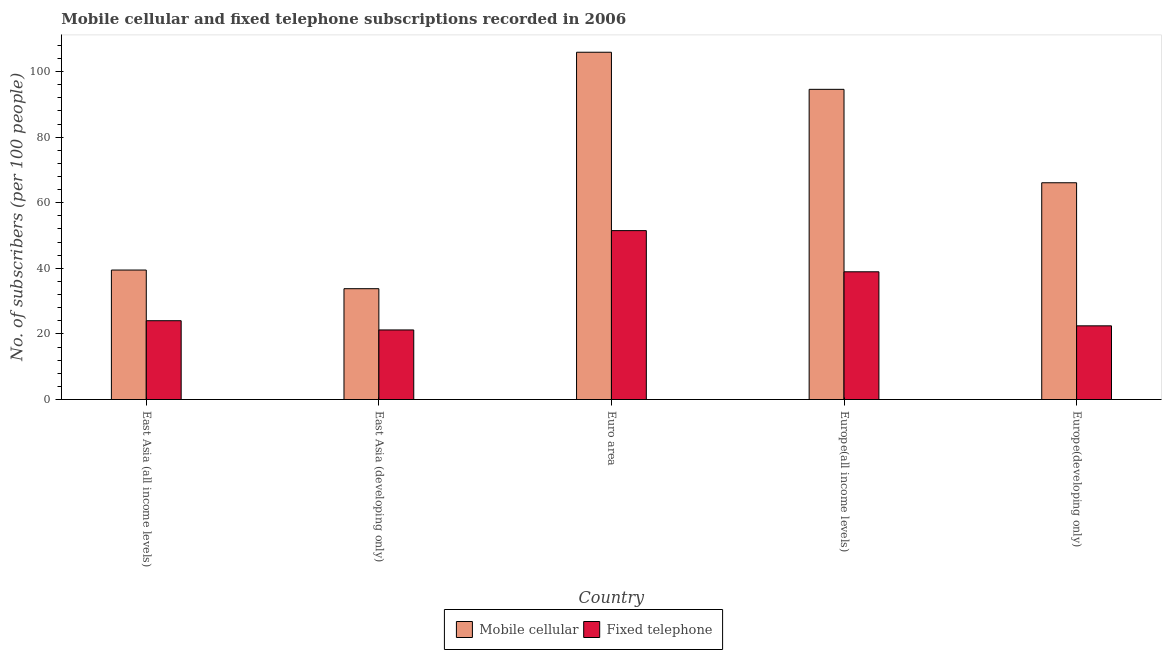How many groups of bars are there?
Give a very brief answer. 5. Are the number of bars on each tick of the X-axis equal?
Offer a very short reply. Yes. How many bars are there on the 4th tick from the right?
Make the answer very short. 2. What is the number of mobile cellular subscribers in Europe(developing only)?
Provide a succinct answer. 66.09. Across all countries, what is the maximum number of mobile cellular subscribers?
Ensure brevity in your answer.  105.89. Across all countries, what is the minimum number of fixed telephone subscribers?
Offer a very short reply. 21.21. In which country was the number of fixed telephone subscribers maximum?
Your answer should be compact. Euro area. In which country was the number of fixed telephone subscribers minimum?
Keep it short and to the point. East Asia (developing only). What is the total number of mobile cellular subscribers in the graph?
Make the answer very short. 339.83. What is the difference between the number of mobile cellular subscribers in Euro area and that in Europe(all income levels)?
Give a very brief answer. 11.31. What is the difference between the number of fixed telephone subscribers in East Asia (developing only) and the number of mobile cellular subscribers in Europe(all income levels)?
Ensure brevity in your answer.  -73.36. What is the average number of fixed telephone subscribers per country?
Keep it short and to the point. 31.63. What is the difference between the number of mobile cellular subscribers and number of fixed telephone subscribers in East Asia (developing only)?
Your answer should be compact. 12.58. What is the ratio of the number of mobile cellular subscribers in East Asia (all income levels) to that in Europe(all income levels)?
Ensure brevity in your answer.  0.42. Is the difference between the number of mobile cellular subscribers in East Asia (developing only) and Euro area greater than the difference between the number of fixed telephone subscribers in East Asia (developing only) and Euro area?
Your answer should be very brief. No. What is the difference between the highest and the second highest number of mobile cellular subscribers?
Offer a terse response. 11.31. What is the difference between the highest and the lowest number of fixed telephone subscribers?
Provide a short and direct response. 30.28. Is the sum of the number of mobile cellular subscribers in Euro area and Europe(all income levels) greater than the maximum number of fixed telephone subscribers across all countries?
Offer a very short reply. Yes. What does the 1st bar from the left in East Asia (developing only) represents?
Give a very brief answer. Mobile cellular. What does the 1st bar from the right in Europe(developing only) represents?
Provide a short and direct response. Fixed telephone. How many bars are there?
Your response must be concise. 10. Are all the bars in the graph horizontal?
Offer a terse response. No. How many countries are there in the graph?
Keep it short and to the point. 5. Are the values on the major ticks of Y-axis written in scientific E-notation?
Give a very brief answer. No. Does the graph contain any zero values?
Ensure brevity in your answer.  No. How many legend labels are there?
Offer a very short reply. 2. How are the legend labels stacked?
Ensure brevity in your answer.  Horizontal. What is the title of the graph?
Give a very brief answer. Mobile cellular and fixed telephone subscriptions recorded in 2006. What is the label or title of the X-axis?
Provide a short and direct response. Country. What is the label or title of the Y-axis?
Offer a terse response. No. of subscribers (per 100 people). What is the No. of subscribers (per 100 people) in Mobile cellular in East Asia (all income levels)?
Your answer should be compact. 39.48. What is the No. of subscribers (per 100 people) of Fixed telephone in East Asia (all income levels)?
Your response must be concise. 24.03. What is the No. of subscribers (per 100 people) of Mobile cellular in East Asia (developing only)?
Your answer should be very brief. 33.79. What is the No. of subscribers (per 100 people) of Fixed telephone in East Asia (developing only)?
Keep it short and to the point. 21.21. What is the No. of subscribers (per 100 people) in Mobile cellular in Euro area?
Your answer should be very brief. 105.89. What is the No. of subscribers (per 100 people) in Fixed telephone in Euro area?
Your response must be concise. 51.5. What is the No. of subscribers (per 100 people) in Mobile cellular in Europe(all income levels)?
Make the answer very short. 94.58. What is the No. of subscribers (per 100 people) of Fixed telephone in Europe(all income levels)?
Keep it short and to the point. 38.94. What is the No. of subscribers (per 100 people) of Mobile cellular in Europe(developing only)?
Offer a terse response. 66.09. What is the No. of subscribers (per 100 people) of Fixed telephone in Europe(developing only)?
Give a very brief answer. 22.47. Across all countries, what is the maximum No. of subscribers (per 100 people) in Mobile cellular?
Provide a succinct answer. 105.89. Across all countries, what is the maximum No. of subscribers (per 100 people) of Fixed telephone?
Your answer should be compact. 51.5. Across all countries, what is the minimum No. of subscribers (per 100 people) in Mobile cellular?
Your response must be concise. 33.79. Across all countries, what is the minimum No. of subscribers (per 100 people) of Fixed telephone?
Your answer should be compact. 21.21. What is the total No. of subscribers (per 100 people) in Mobile cellular in the graph?
Ensure brevity in your answer.  339.83. What is the total No. of subscribers (per 100 people) in Fixed telephone in the graph?
Your response must be concise. 158.16. What is the difference between the No. of subscribers (per 100 people) in Mobile cellular in East Asia (all income levels) and that in East Asia (developing only)?
Your response must be concise. 5.69. What is the difference between the No. of subscribers (per 100 people) in Fixed telephone in East Asia (all income levels) and that in East Asia (developing only)?
Provide a succinct answer. 2.81. What is the difference between the No. of subscribers (per 100 people) in Mobile cellular in East Asia (all income levels) and that in Euro area?
Your answer should be compact. -66.41. What is the difference between the No. of subscribers (per 100 people) of Fixed telephone in East Asia (all income levels) and that in Euro area?
Offer a terse response. -27.47. What is the difference between the No. of subscribers (per 100 people) in Mobile cellular in East Asia (all income levels) and that in Europe(all income levels)?
Provide a succinct answer. -55.1. What is the difference between the No. of subscribers (per 100 people) of Fixed telephone in East Asia (all income levels) and that in Europe(all income levels)?
Offer a terse response. -14.92. What is the difference between the No. of subscribers (per 100 people) of Mobile cellular in East Asia (all income levels) and that in Europe(developing only)?
Offer a terse response. -26.62. What is the difference between the No. of subscribers (per 100 people) in Fixed telephone in East Asia (all income levels) and that in Europe(developing only)?
Keep it short and to the point. 1.56. What is the difference between the No. of subscribers (per 100 people) of Mobile cellular in East Asia (developing only) and that in Euro area?
Offer a very short reply. -72.1. What is the difference between the No. of subscribers (per 100 people) of Fixed telephone in East Asia (developing only) and that in Euro area?
Provide a short and direct response. -30.28. What is the difference between the No. of subscribers (per 100 people) in Mobile cellular in East Asia (developing only) and that in Europe(all income levels)?
Your response must be concise. -60.79. What is the difference between the No. of subscribers (per 100 people) in Fixed telephone in East Asia (developing only) and that in Europe(all income levels)?
Offer a terse response. -17.73. What is the difference between the No. of subscribers (per 100 people) of Mobile cellular in East Asia (developing only) and that in Europe(developing only)?
Ensure brevity in your answer.  -32.3. What is the difference between the No. of subscribers (per 100 people) in Fixed telephone in East Asia (developing only) and that in Europe(developing only)?
Your response must be concise. -1.25. What is the difference between the No. of subscribers (per 100 people) of Mobile cellular in Euro area and that in Europe(all income levels)?
Provide a succinct answer. 11.31. What is the difference between the No. of subscribers (per 100 people) of Fixed telephone in Euro area and that in Europe(all income levels)?
Give a very brief answer. 12.55. What is the difference between the No. of subscribers (per 100 people) of Mobile cellular in Euro area and that in Europe(developing only)?
Provide a succinct answer. 39.79. What is the difference between the No. of subscribers (per 100 people) of Fixed telephone in Euro area and that in Europe(developing only)?
Make the answer very short. 29.03. What is the difference between the No. of subscribers (per 100 people) of Mobile cellular in Europe(all income levels) and that in Europe(developing only)?
Offer a very short reply. 28.48. What is the difference between the No. of subscribers (per 100 people) of Fixed telephone in Europe(all income levels) and that in Europe(developing only)?
Make the answer very short. 16.48. What is the difference between the No. of subscribers (per 100 people) of Mobile cellular in East Asia (all income levels) and the No. of subscribers (per 100 people) of Fixed telephone in East Asia (developing only)?
Give a very brief answer. 18.26. What is the difference between the No. of subscribers (per 100 people) in Mobile cellular in East Asia (all income levels) and the No. of subscribers (per 100 people) in Fixed telephone in Euro area?
Your answer should be very brief. -12.02. What is the difference between the No. of subscribers (per 100 people) in Mobile cellular in East Asia (all income levels) and the No. of subscribers (per 100 people) in Fixed telephone in Europe(all income levels)?
Ensure brevity in your answer.  0.53. What is the difference between the No. of subscribers (per 100 people) in Mobile cellular in East Asia (all income levels) and the No. of subscribers (per 100 people) in Fixed telephone in Europe(developing only)?
Give a very brief answer. 17.01. What is the difference between the No. of subscribers (per 100 people) of Mobile cellular in East Asia (developing only) and the No. of subscribers (per 100 people) of Fixed telephone in Euro area?
Your answer should be very brief. -17.71. What is the difference between the No. of subscribers (per 100 people) of Mobile cellular in East Asia (developing only) and the No. of subscribers (per 100 people) of Fixed telephone in Europe(all income levels)?
Make the answer very short. -5.15. What is the difference between the No. of subscribers (per 100 people) in Mobile cellular in East Asia (developing only) and the No. of subscribers (per 100 people) in Fixed telephone in Europe(developing only)?
Keep it short and to the point. 11.32. What is the difference between the No. of subscribers (per 100 people) of Mobile cellular in Euro area and the No. of subscribers (per 100 people) of Fixed telephone in Europe(all income levels)?
Provide a succinct answer. 66.94. What is the difference between the No. of subscribers (per 100 people) in Mobile cellular in Euro area and the No. of subscribers (per 100 people) in Fixed telephone in Europe(developing only)?
Your response must be concise. 83.42. What is the difference between the No. of subscribers (per 100 people) in Mobile cellular in Europe(all income levels) and the No. of subscribers (per 100 people) in Fixed telephone in Europe(developing only)?
Your answer should be compact. 72.11. What is the average No. of subscribers (per 100 people) in Mobile cellular per country?
Keep it short and to the point. 67.97. What is the average No. of subscribers (per 100 people) of Fixed telephone per country?
Ensure brevity in your answer.  31.63. What is the difference between the No. of subscribers (per 100 people) in Mobile cellular and No. of subscribers (per 100 people) in Fixed telephone in East Asia (all income levels)?
Keep it short and to the point. 15.45. What is the difference between the No. of subscribers (per 100 people) in Mobile cellular and No. of subscribers (per 100 people) in Fixed telephone in East Asia (developing only)?
Make the answer very short. 12.58. What is the difference between the No. of subscribers (per 100 people) in Mobile cellular and No. of subscribers (per 100 people) in Fixed telephone in Euro area?
Your answer should be very brief. 54.39. What is the difference between the No. of subscribers (per 100 people) of Mobile cellular and No. of subscribers (per 100 people) of Fixed telephone in Europe(all income levels)?
Provide a short and direct response. 55.63. What is the difference between the No. of subscribers (per 100 people) in Mobile cellular and No. of subscribers (per 100 people) in Fixed telephone in Europe(developing only)?
Keep it short and to the point. 43.63. What is the ratio of the No. of subscribers (per 100 people) in Mobile cellular in East Asia (all income levels) to that in East Asia (developing only)?
Offer a very short reply. 1.17. What is the ratio of the No. of subscribers (per 100 people) of Fixed telephone in East Asia (all income levels) to that in East Asia (developing only)?
Your answer should be compact. 1.13. What is the ratio of the No. of subscribers (per 100 people) of Mobile cellular in East Asia (all income levels) to that in Euro area?
Offer a very short reply. 0.37. What is the ratio of the No. of subscribers (per 100 people) in Fixed telephone in East Asia (all income levels) to that in Euro area?
Offer a terse response. 0.47. What is the ratio of the No. of subscribers (per 100 people) of Mobile cellular in East Asia (all income levels) to that in Europe(all income levels)?
Provide a short and direct response. 0.42. What is the ratio of the No. of subscribers (per 100 people) of Fixed telephone in East Asia (all income levels) to that in Europe(all income levels)?
Your answer should be very brief. 0.62. What is the ratio of the No. of subscribers (per 100 people) in Mobile cellular in East Asia (all income levels) to that in Europe(developing only)?
Make the answer very short. 0.6. What is the ratio of the No. of subscribers (per 100 people) in Fixed telephone in East Asia (all income levels) to that in Europe(developing only)?
Provide a succinct answer. 1.07. What is the ratio of the No. of subscribers (per 100 people) in Mobile cellular in East Asia (developing only) to that in Euro area?
Offer a terse response. 0.32. What is the ratio of the No. of subscribers (per 100 people) in Fixed telephone in East Asia (developing only) to that in Euro area?
Provide a succinct answer. 0.41. What is the ratio of the No. of subscribers (per 100 people) of Mobile cellular in East Asia (developing only) to that in Europe(all income levels)?
Your answer should be very brief. 0.36. What is the ratio of the No. of subscribers (per 100 people) in Fixed telephone in East Asia (developing only) to that in Europe(all income levels)?
Provide a succinct answer. 0.54. What is the ratio of the No. of subscribers (per 100 people) in Mobile cellular in East Asia (developing only) to that in Europe(developing only)?
Your answer should be compact. 0.51. What is the ratio of the No. of subscribers (per 100 people) of Fixed telephone in East Asia (developing only) to that in Europe(developing only)?
Offer a very short reply. 0.94. What is the ratio of the No. of subscribers (per 100 people) of Mobile cellular in Euro area to that in Europe(all income levels)?
Offer a very short reply. 1.12. What is the ratio of the No. of subscribers (per 100 people) in Fixed telephone in Euro area to that in Europe(all income levels)?
Provide a succinct answer. 1.32. What is the ratio of the No. of subscribers (per 100 people) in Mobile cellular in Euro area to that in Europe(developing only)?
Provide a succinct answer. 1.6. What is the ratio of the No. of subscribers (per 100 people) of Fixed telephone in Euro area to that in Europe(developing only)?
Provide a short and direct response. 2.29. What is the ratio of the No. of subscribers (per 100 people) in Mobile cellular in Europe(all income levels) to that in Europe(developing only)?
Give a very brief answer. 1.43. What is the ratio of the No. of subscribers (per 100 people) of Fixed telephone in Europe(all income levels) to that in Europe(developing only)?
Give a very brief answer. 1.73. What is the difference between the highest and the second highest No. of subscribers (per 100 people) in Mobile cellular?
Make the answer very short. 11.31. What is the difference between the highest and the second highest No. of subscribers (per 100 people) in Fixed telephone?
Your answer should be compact. 12.55. What is the difference between the highest and the lowest No. of subscribers (per 100 people) in Mobile cellular?
Ensure brevity in your answer.  72.1. What is the difference between the highest and the lowest No. of subscribers (per 100 people) of Fixed telephone?
Offer a terse response. 30.28. 